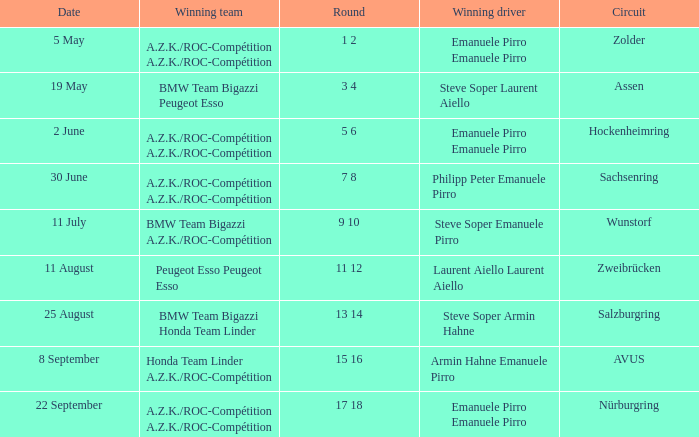What is the date of the zolder circuit, which had a.z.k./roc-compétition a.z.k./roc-compétition as the winning team? 5 May. Can you parse all the data within this table? {'header': ['Date', 'Winning team', 'Round', 'Winning driver', 'Circuit'], 'rows': [['5 May', 'A.Z.K./ROC-Compétition A.Z.K./ROC-Compétition', '1 2', 'Emanuele Pirro Emanuele Pirro', 'Zolder'], ['19 May', 'BMW Team Bigazzi Peugeot Esso', '3 4', 'Steve Soper Laurent Aiello', 'Assen'], ['2 June', 'A.Z.K./ROC-Compétition A.Z.K./ROC-Compétition', '5 6', 'Emanuele Pirro Emanuele Pirro', 'Hockenheimring'], ['30 June', 'A.Z.K./ROC-Compétition A.Z.K./ROC-Compétition', '7 8', 'Philipp Peter Emanuele Pirro', 'Sachsenring'], ['11 July', 'BMW Team Bigazzi A.Z.K./ROC-Compétition', '9 10', 'Steve Soper Emanuele Pirro', 'Wunstorf'], ['11 August', 'Peugeot Esso Peugeot Esso', '11 12', 'Laurent Aiello Laurent Aiello', 'Zweibrücken'], ['25 August', 'BMW Team Bigazzi Honda Team Linder', '13 14', 'Steve Soper Armin Hahne', 'Salzburgring'], ['8 September', 'Honda Team Linder A.Z.K./ROC-Compétition', '15 16', 'Armin Hahne Emanuele Pirro', 'AVUS'], ['22 September', 'A.Z.K./ROC-Compétition A.Z.K./ROC-Compétition', '17 18', 'Emanuele Pirro Emanuele Pirro', 'Nürburgring']]} 